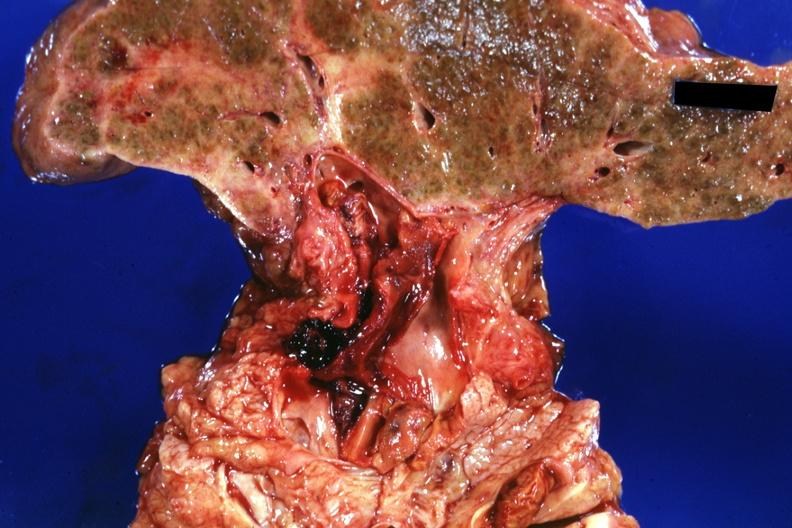s liver present?
Answer the question using a single word or phrase. Yes 